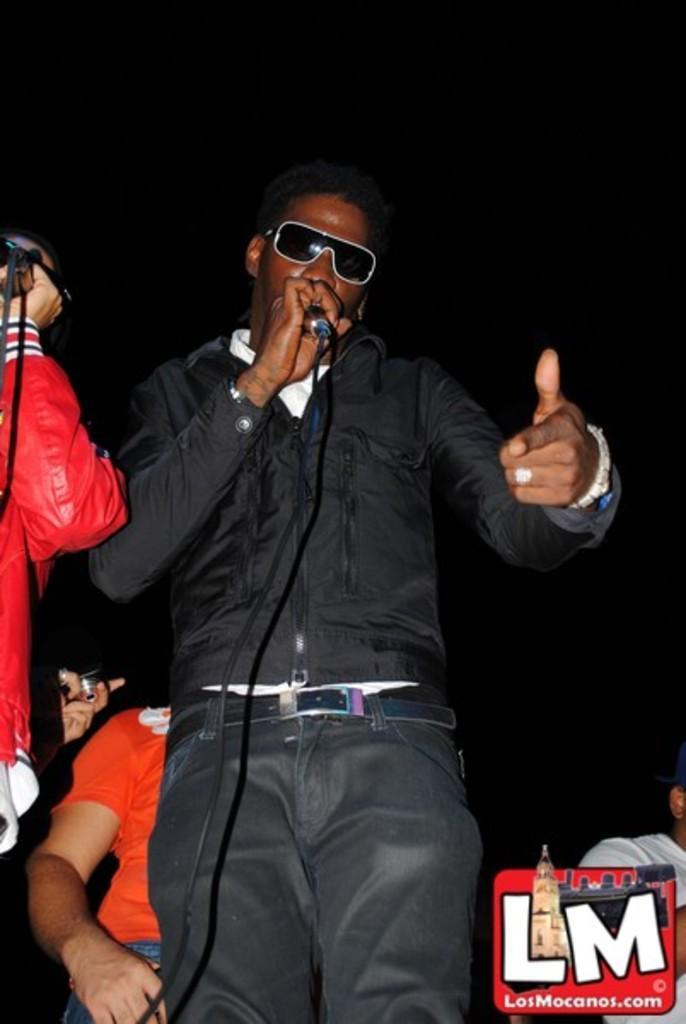In one or two sentences, can you explain what this image depicts? This is the picture of a person wearing black shirt and holding a microphone and standing. There are few persons in the background among them one is holding camera. 